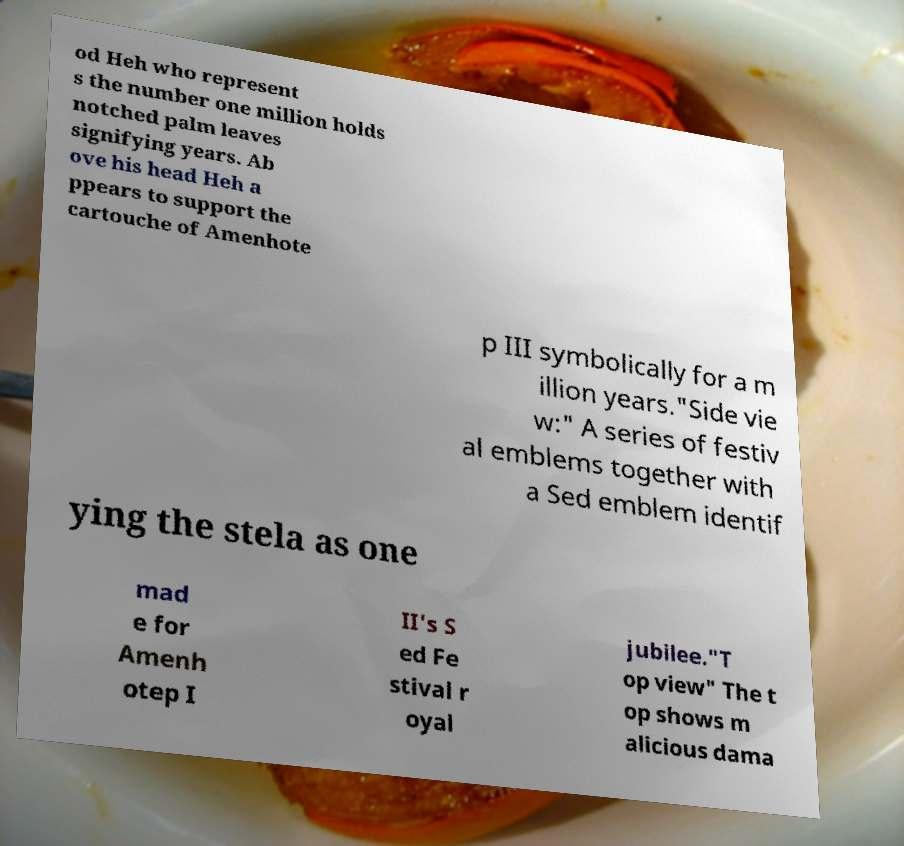Can you accurately transcribe the text from the provided image for me? od Heh who represent s the number one million holds notched palm leaves signifying years. Ab ove his head Heh a ppears to support the cartouche of Amenhote p III symbolically for a m illion years."Side vie w:" A series of festiv al emblems together with a Sed emblem identif ying the stela as one mad e for Amenh otep I II's S ed Fe stival r oyal jubilee."T op view" The t op shows m alicious dama 